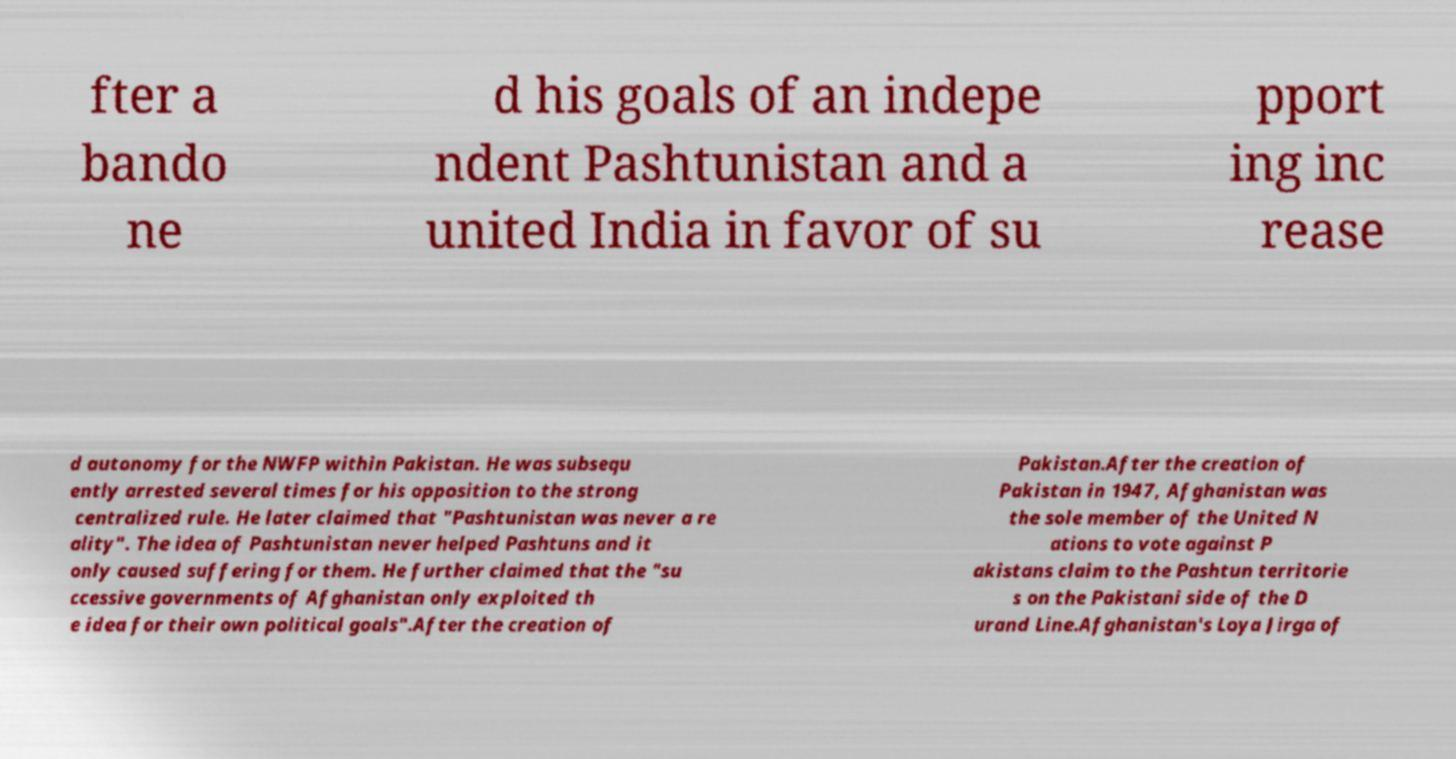I need the written content from this picture converted into text. Can you do that? fter a bando ne d his goals of an indepe ndent Pashtunistan and a united India in favor of su pport ing inc rease d autonomy for the NWFP within Pakistan. He was subsequ ently arrested several times for his opposition to the strong centralized rule. He later claimed that "Pashtunistan was never a re ality". The idea of Pashtunistan never helped Pashtuns and it only caused suffering for them. He further claimed that the "su ccessive governments of Afghanistan only exploited th e idea for their own political goals".After the creation of Pakistan.After the creation of Pakistan in 1947, Afghanistan was the sole member of the United N ations to vote against P akistans claim to the Pashtun territorie s on the Pakistani side of the D urand Line.Afghanistan's Loya Jirga of 